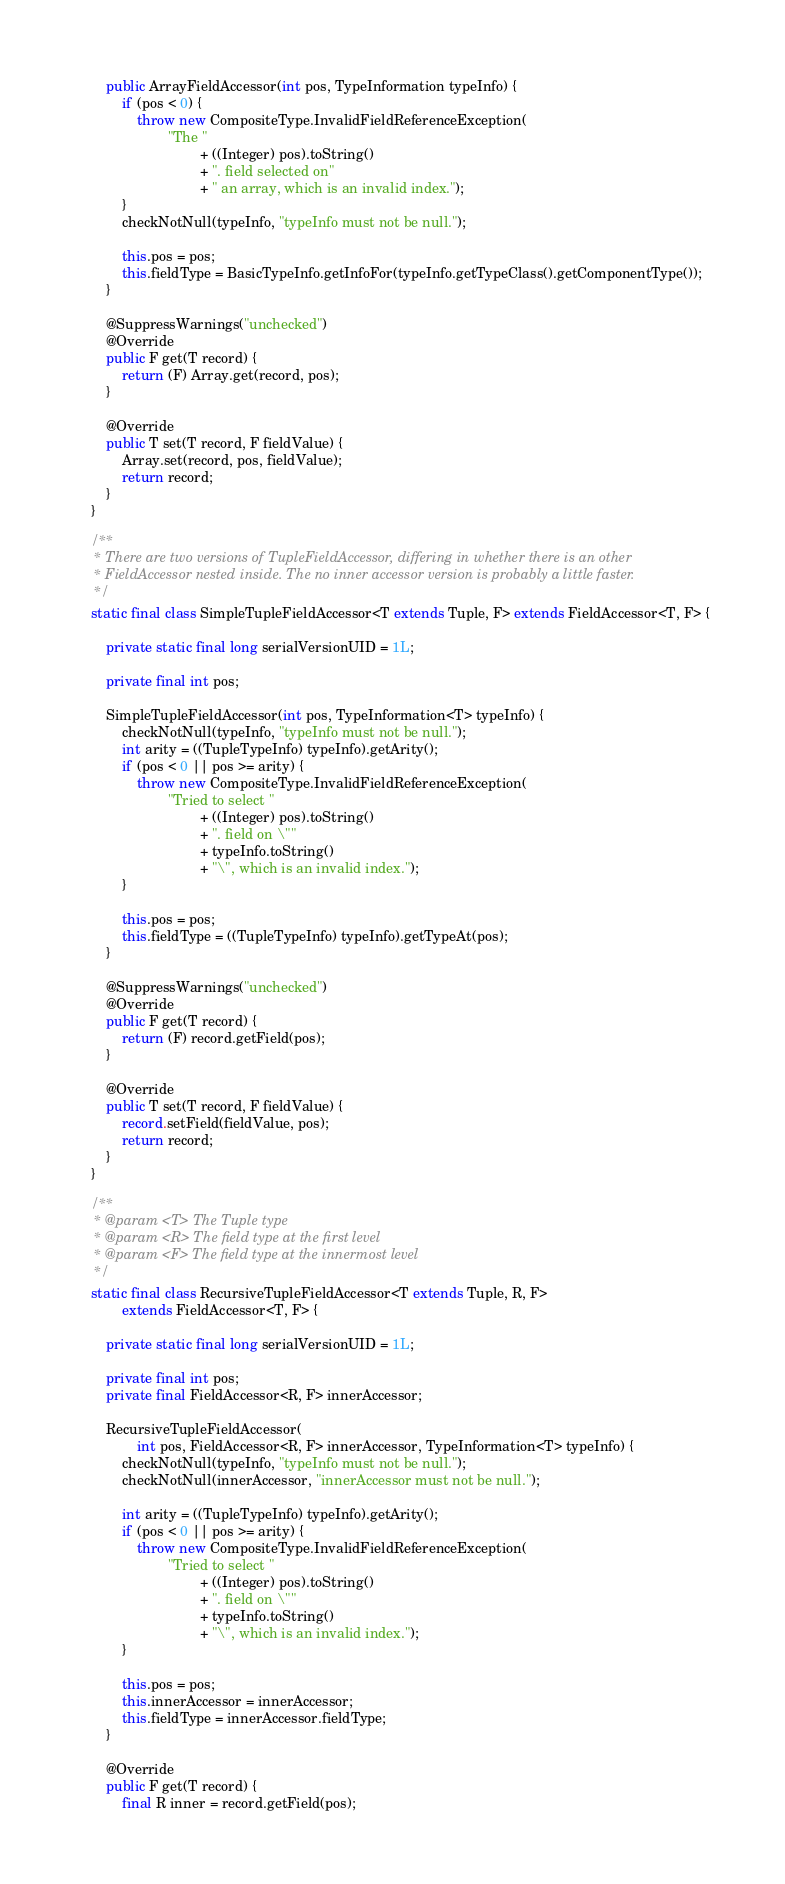<code> <loc_0><loc_0><loc_500><loc_500><_Java_>        public ArrayFieldAccessor(int pos, TypeInformation typeInfo) {
            if (pos < 0) {
                throw new CompositeType.InvalidFieldReferenceException(
                        "The "
                                + ((Integer) pos).toString()
                                + ". field selected on"
                                + " an array, which is an invalid index.");
            }
            checkNotNull(typeInfo, "typeInfo must not be null.");

            this.pos = pos;
            this.fieldType = BasicTypeInfo.getInfoFor(typeInfo.getTypeClass().getComponentType());
        }

        @SuppressWarnings("unchecked")
        @Override
        public F get(T record) {
            return (F) Array.get(record, pos);
        }

        @Override
        public T set(T record, F fieldValue) {
            Array.set(record, pos, fieldValue);
            return record;
        }
    }

    /**
     * There are two versions of TupleFieldAccessor, differing in whether there is an other
     * FieldAccessor nested inside. The no inner accessor version is probably a little faster.
     */
    static final class SimpleTupleFieldAccessor<T extends Tuple, F> extends FieldAccessor<T, F> {

        private static final long serialVersionUID = 1L;

        private final int pos;

        SimpleTupleFieldAccessor(int pos, TypeInformation<T> typeInfo) {
            checkNotNull(typeInfo, "typeInfo must not be null.");
            int arity = ((TupleTypeInfo) typeInfo).getArity();
            if (pos < 0 || pos >= arity) {
                throw new CompositeType.InvalidFieldReferenceException(
                        "Tried to select "
                                + ((Integer) pos).toString()
                                + ". field on \""
                                + typeInfo.toString()
                                + "\", which is an invalid index.");
            }

            this.pos = pos;
            this.fieldType = ((TupleTypeInfo) typeInfo).getTypeAt(pos);
        }

        @SuppressWarnings("unchecked")
        @Override
        public F get(T record) {
            return (F) record.getField(pos);
        }

        @Override
        public T set(T record, F fieldValue) {
            record.setField(fieldValue, pos);
            return record;
        }
    }

    /**
     * @param <T> The Tuple type
     * @param <R> The field type at the first level
     * @param <F> The field type at the innermost level
     */
    static final class RecursiveTupleFieldAccessor<T extends Tuple, R, F>
            extends FieldAccessor<T, F> {

        private static final long serialVersionUID = 1L;

        private final int pos;
        private final FieldAccessor<R, F> innerAccessor;

        RecursiveTupleFieldAccessor(
                int pos, FieldAccessor<R, F> innerAccessor, TypeInformation<T> typeInfo) {
            checkNotNull(typeInfo, "typeInfo must not be null.");
            checkNotNull(innerAccessor, "innerAccessor must not be null.");

            int arity = ((TupleTypeInfo) typeInfo).getArity();
            if (pos < 0 || pos >= arity) {
                throw new CompositeType.InvalidFieldReferenceException(
                        "Tried to select "
                                + ((Integer) pos).toString()
                                + ". field on \""
                                + typeInfo.toString()
                                + "\", which is an invalid index.");
            }

            this.pos = pos;
            this.innerAccessor = innerAccessor;
            this.fieldType = innerAccessor.fieldType;
        }

        @Override
        public F get(T record) {
            final R inner = record.getField(pos);</code> 